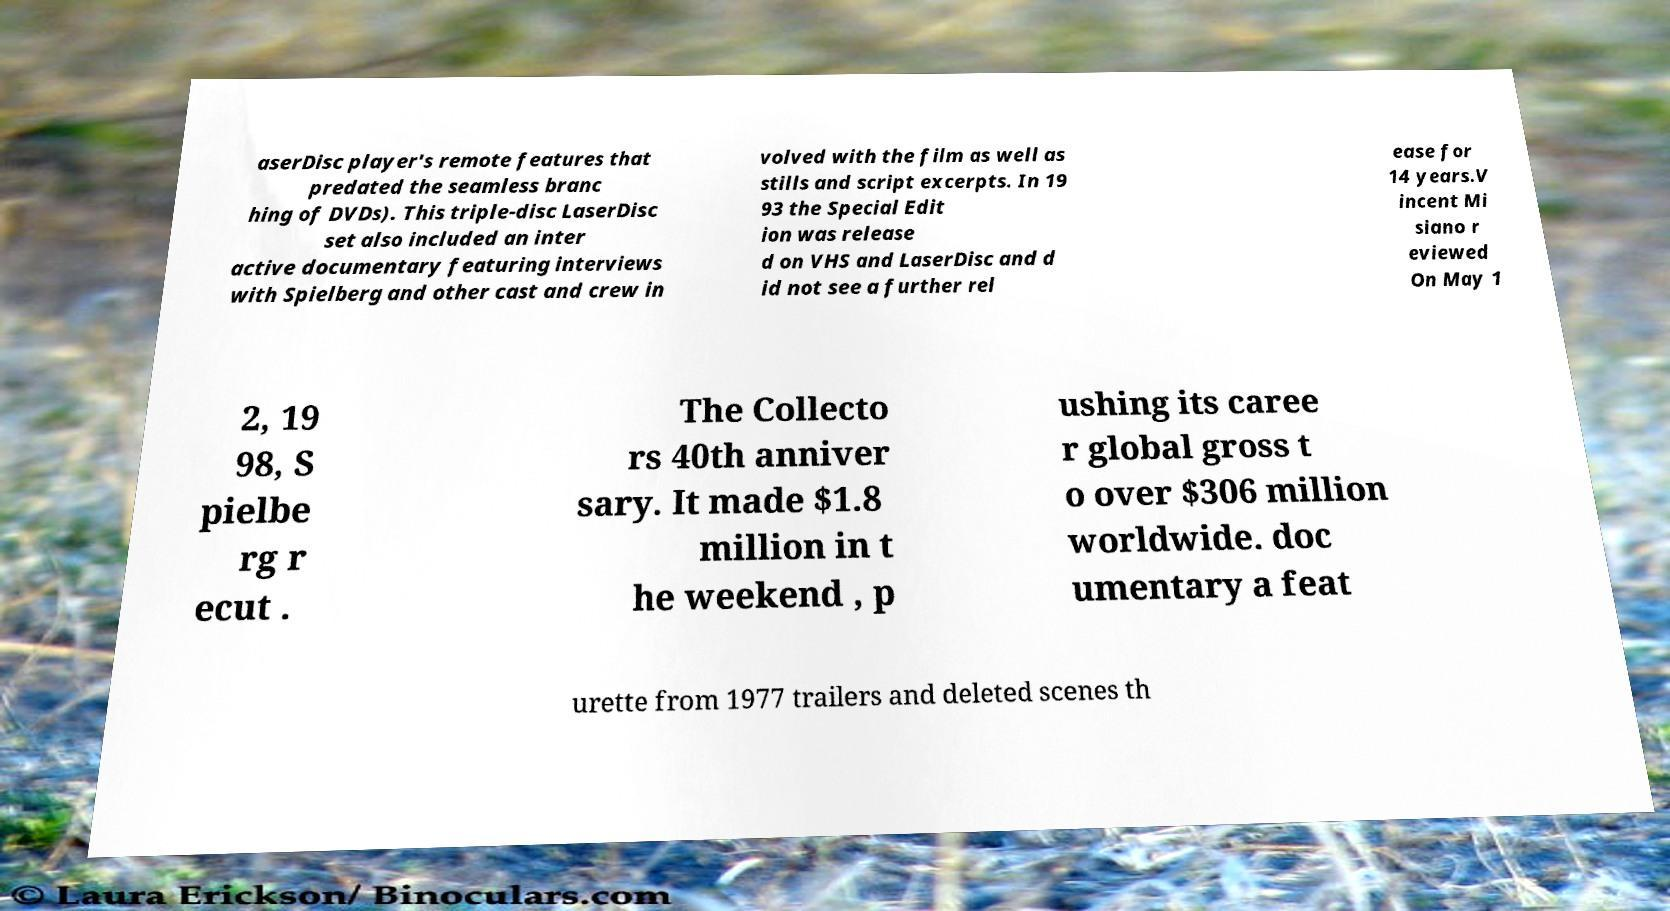Please read and relay the text visible in this image. What does it say? aserDisc player's remote features that predated the seamless branc hing of DVDs). This triple-disc LaserDisc set also included an inter active documentary featuring interviews with Spielberg and other cast and crew in volved with the film as well as stills and script excerpts. In 19 93 the Special Edit ion was release d on VHS and LaserDisc and d id not see a further rel ease for 14 years.V incent Mi siano r eviewed On May 1 2, 19 98, S pielbe rg r ecut . The Collecto rs 40th anniver sary. It made $1.8 million in t he weekend , p ushing its caree r global gross t o over $306 million worldwide. doc umentary a feat urette from 1977 trailers and deleted scenes th 